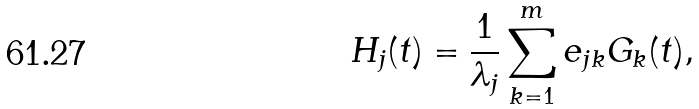Convert formula to latex. <formula><loc_0><loc_0><loc_500><loc_500>H _ { j } ( t ) = \frac { 1 } { \lambda _ { j } } \sum _ { k = 1 } ^ { m } e _ { j k } G _ { k } ( t ) ,</formula> 